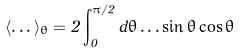Convert formula to latex. <formula><loc_0><loc_0><loc_500><loc_500>\langle \dots \rangle _ { \theta } = 2 \int _ { 0 } ^ { \pi / 2 } d \theta \dots \sin \theta \cos \theta</formula> 